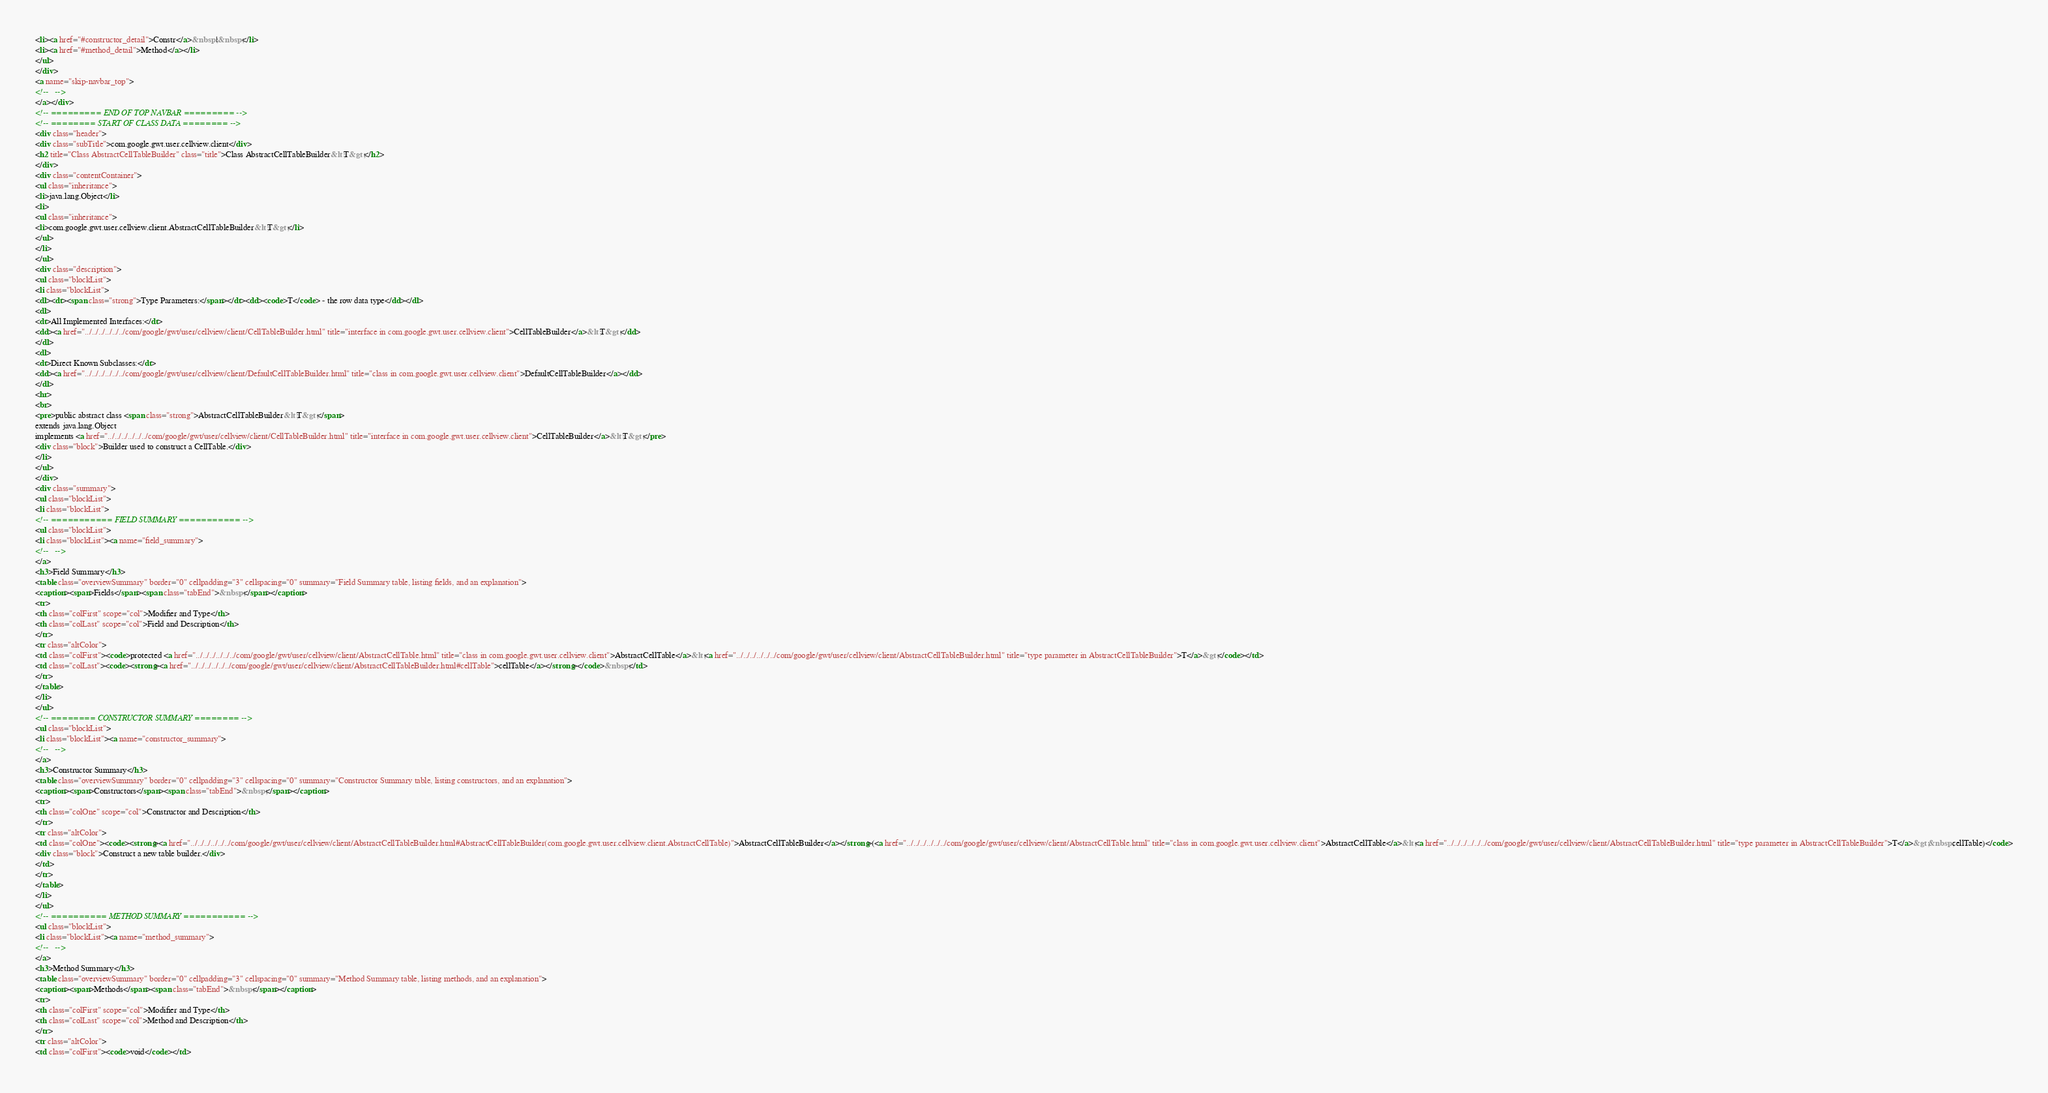Convert code to text. <code><loc_0><loc_0><loc_500><loc_500><_HTML_><li><a href="#constructor_detail">Constr</a>&nbsp;|&nbsp;</li>
<li><a href="#method_detail">Method</a></li>
</ul>
</div>
<a name="skip-navbar_top">
<!--   -->
</a></div>
<!-- ========= END OF TOP NAVBAR ========= -->
<!-- ======== START OF CLASS DATA ======== -->
<div class="header">
<div class="subTitle">com.google.gwt.user.cellview.client</div>
<h2 title="Class AbstractCellTableBuilder" class="title">Class AbstractCellTableBuilder&lt;T&gt;</h2>
</div>
<div class="contentContainer">
<ul class="inheritance">
<li>java.lang.Object</li>
<li>
<ul class="inheritance">
<li>com.google.gwt.user.cellview.client.AbstractCellTableBuilder&lt;T&gt;</li>
</ul>
</li>
</ul>
<div class="description">
<ul class="blockList">
<li class="blockList">
<dl><dt><span class="strong">Type Parameters:</span></dt><dd><code>T</code> - the row data type</dd></dl>
<dl>
<dt>All Implemented Interfaces:</dt>
<dd><a href="../../../../../../com/google/gwt/user/cellview/client/CellTableBuilder.html" title="interface in com.google.gwt.user.cellview.client">CellTableBuilder</a>&lt;T&gt;</dd>
</dl>
<dl>
<dt>Direct Known Subclasses:</dt>
<dd><a href="../../../../../../com/google/gwt/user/cellview/client/DefaultCellTableBuilder.html" title="class in com.google.gwt.user.cellview.client">DefaultCellTableBuilder</a></dd>
</dl>
<hr>
<br>
<pre>public abstract class <span class="strong">AbstractCellTableBuilder&lt;T&gt;</span>
extends java.lang.Object
implements <a href="../../../../../../com/google/gwt/user/cellview/client/CellTableBuilder.html" title="interface in com.google.gwt.user.cellview.client">CellTableBuilder</a>&lt;T&gt;</pre>
<div class="block">Builder used to construct a CellTable.</div>
</li>
</ul>
</div>
<div class="summary">
<ul class="blockList">
<li class="blockList">
<!-- =========== FIELD SUMMARY =========== -->
<ul class="blockList">
<li class="blockList"><a name="field_summary">
<!--   -->
</a>
<h3>Field Summary</h3>
<table class="overviewSummary" border="0" cellpadding="3" cellspacing="0" summary="Field Summary table, listing fields, and an explanation">
<caption><span>Fields</span><span class="tabEnd">&nbsp;</span></caption>
<tr>
<th class="colFirst" scope="col">Modifier and Type</th>
<th class="colLast" scope="col">Field and Description</th>
</tr>
<tr class="altColor">
<td class="colFirst"><code>protected <a href="../../../../../../com/google/gwt/user/cellview/client/AbstractCellTable.html" title="class in com.google.gwt.user.cellview.client">AbstractCellTable</a>&lt;<a href="../../../../../../com/google/gwt/user/cellview/client/AbstractCellTableBuilder.html" title="type parameter in AbstractCellTableBuilder">T</a>&gt;</code></td>
<td class="colLast"><code><strong><a href="../../../../../../com/google/gwt/user/cellview/client/AbstractCellTableBuilder.html#cellTable">cellTable</a></strong></code>&nbsp;</td>
</tr>
</table>
</li>
</ul>
<!-- ======== CONSTRUCTOR SUMMARY ======== -->
<ul class="blockList">
<li class="blockList"><a name="constructor_summary">
<!--   -->
</a>
<h3>Constructor Summary</h3>
<table class="overviewSummary" border="0" cellpadding="3" cellspacing="0" summary="Constructor Summary table, listing constructors, and an explanation">
<caption><span>Constructors</span><span class="tabEnd">&nbsp;</span></caption>
<tr>
<th class="colOne" scope="col">Constructor and Description</th>
</tr>
<tr class="altColor">
<td class="colOne"><code><strong><a href="../../../../../../com/google/gwt/user/cellview/client/AbstractCellTableBuilder.html#AbstractCellTableBuilder(com.google.gwt.user.cellview.client.AbstractCellTable)">AbstractCellTableBuilder</a></strong>(<a href="../../../../../../com/google/gwt/user/cellview/client/AbstractCellTable.html" title="class in com.google.gwt.user.cellview.client">AbstractCellTable</a>&lt;<a href="../../../../../../com/google/gwt/user/cellview/client/AbstractCellTableBuilder.html" title="type parameter in AbstractCellTableBuilder">T</a>&gt;&nbsp;cellTable)</code>
<div class="block">Construct a new table builder.</div>
</td>
</tr>
</table>
</li>
</ul>
<!-- ========== METHOD SUMMARY =========== -->
<ul class="blockList">
<li class="blockList"><a name="method_summary">
<!--   -->
</a>
<h3>Method Summary</h3>
<table class="overviewSummary" border="0" cellpadding="3" cellspacing="0" summary="Method Summary table, listing methods, and an explanation">
<caption><span>Methods</span><span class="tabEnd">&nbsp;</span></caption>
<tr>
<th class="colFirst" scope="col">Modifier and Type</th>
<th class="colLast" scope="col">Method and Description</th>
</tr>
<tr class="altColor">
<td class="colFirst"><code>void</code></td></code> 